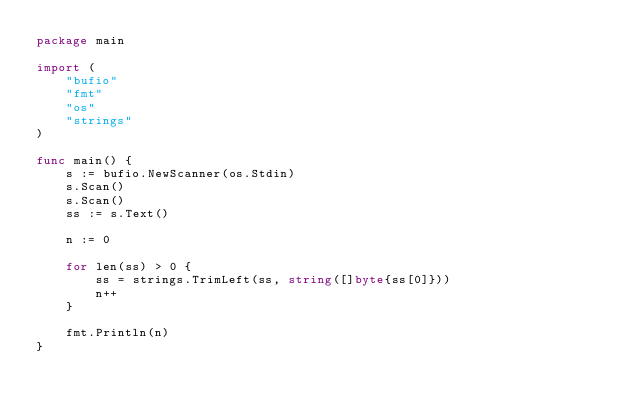Convert code to text. <code><loc_0><loc_0><loc_500><loc_500><_Go_>package main

import (
	"bufio"
	"fmt"
	"os"
	"strings"
)

func main() {
	s := bufio.NewScanner(os.Stdin)
	s.Scan()
	s.Scan()
	ss := s.Text()

	n := 0

	for len(ss) > 0 {
		ss = strings.TrimLeft(ss, string([]byte{ss[0]}))
		n++
	}

	fmt.Println(n)
}
</code> 